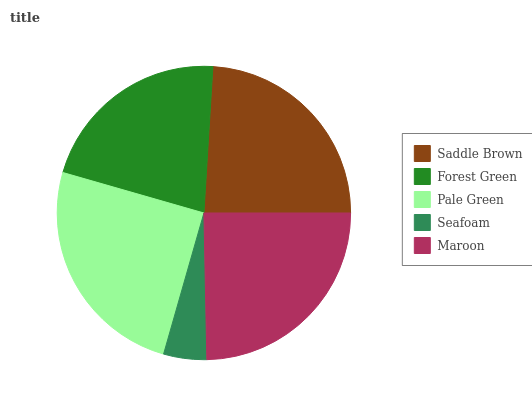Is Seafoam the minimum?
Answer yes or no. Yes. Is Pale Green the maximum?
Answer yes or no. Yes. Is Forest Green the minimum?
Answer yes or no. No. Is Forest Green the maximum?
Answer yes or no. No. Is Saddle Brown greater than Forest Green?
Answer yes or no. Yes. Is Forest Green less than Saddle Brown?
Answer yes or no. Yes. Is Forest Green greater than Saddle Brown?
Answer yes or no. No. Is Saddle Brown less than Forest Green?
Answer yes or no. No. Is Saddle Brown the high median?
Answer yes or no. Yes. Is Saddle Brown the low median?
Answer yes or no. Yes. Is Pale Green the high median?
Answer yes or no. No. Is Forest Green the low median?
Answer yes or no. No. 